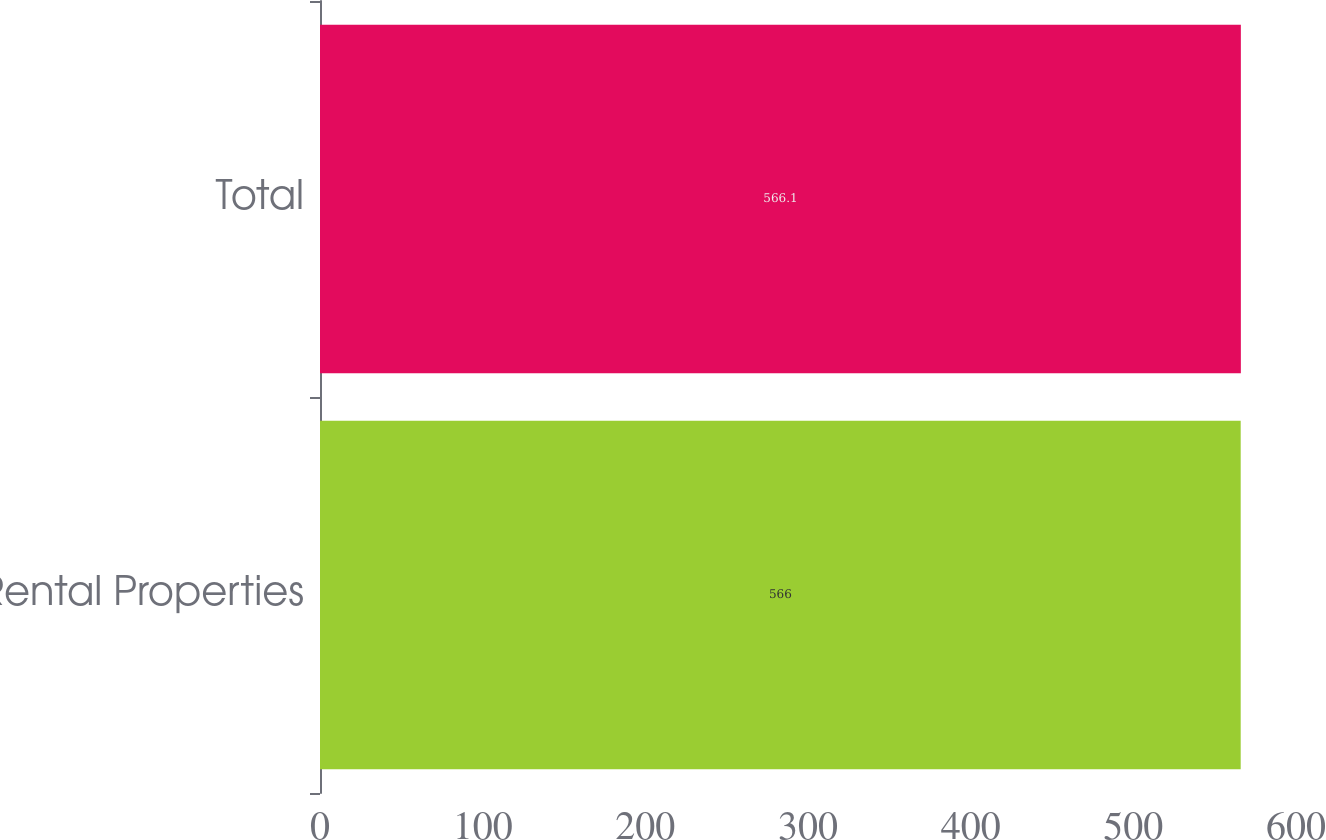<chart> <loc_0><loc_0><loc_500><loc_500><bar_chart><fcel>Rental Properties<fcel>Total<nl><fcel>566<fcel>566.1<nl></chart> 